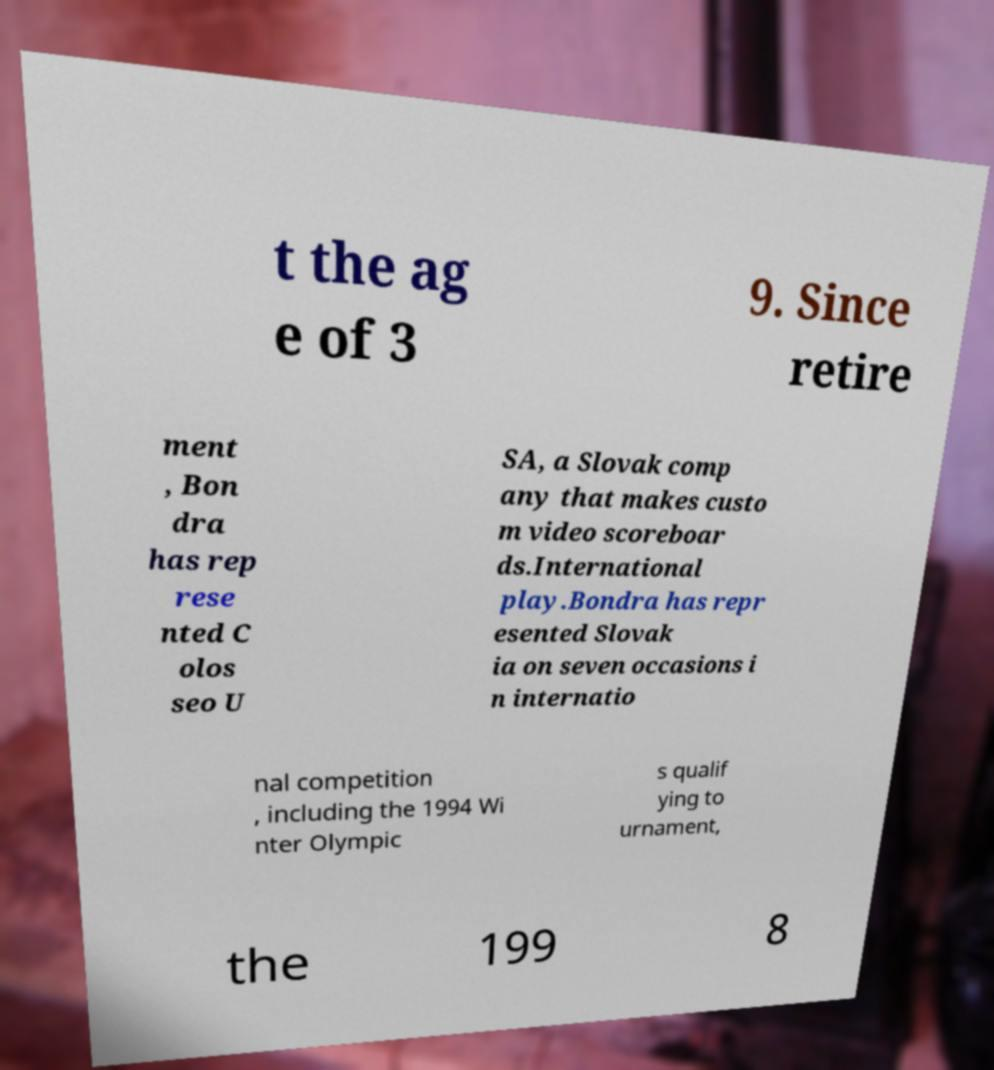There's text embedded in this image that I need extracted. Can you transcribe it verbatim? t the ag e of 3 9. Since retire ment , Bon dra has rep rese nted C olos seo U SA, a Slovak comp any that makes custo m video scoreboar ds.International play.Bondra has repr esented Slovak ia on seven occasions i n internatio nal competition , including the 1994 Wi nter Olympic s qualif ying to urnament, the 199 8 